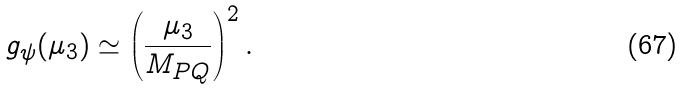<formula> <loc_0><loc_0><loc_500><loc_500>g _ { \psi } ( \mu _ { 3 } ) \simeq \left ( \frac { \mu _ { 3 } } { M _ { P Q } } \right ) ^ { 2 } .</formula> 